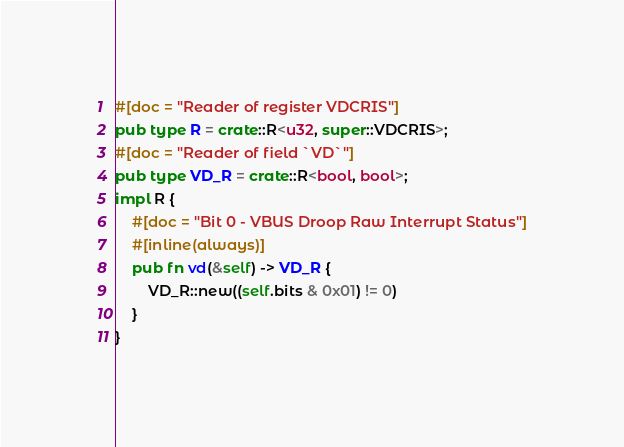Convert code to text. <code><loc_0><loc_0><loc_500><loc_500><_Rust_>#[doc = "Reader of register VDCRIS"]
pub type R = crate::R<u32, super::VDCRIS>;
#[doc = "Reader of field `VD`"]
pub type VD_R = crate::R<bool, bool>;
impl R {
    #[doc = "Bit 0 - VBUS Droop Raw Interrupt Status"]
    #[inline(always)]
    pub fn vd(&self) -> VD_R {
        VD_R::new((self.bits & 0x01) != 0)
    }
}
</code> 